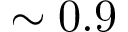Convert formula to latex. <formula><loc_0><loc_0><loc_500><loc_500>\sim 0 . 9</formula> 